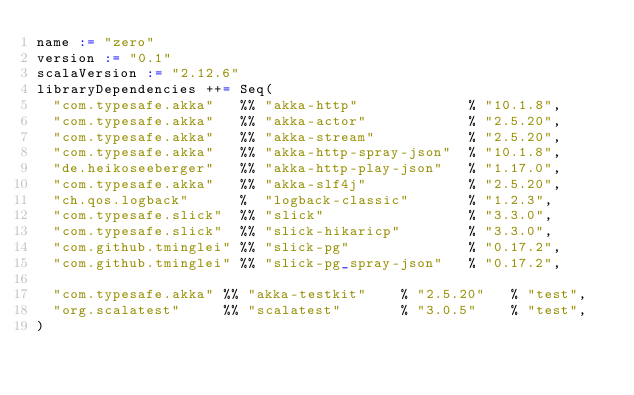<code> <loc_0><loc_0><loc_500><loc_500><_Scala_>name := "zero"
version := "0.1"
scalaVersion := "2.12.6"
libraryDependencies ++= Seq(
  "com.typesafe.akka"   %% "akka-http"             % "10.1.8",
  "com.typesafe.akka"   %% "akka-actor"            % "2.5.20",
  "com.typesafe.akka"   %% "akka-stream"           % "2.5.20",
  "com.typesafe.akka"   %% "akka-http-spray-json"  % "10.1.8",
  "de.heikoseeberger"   %% "akka-http-play-json"   % "1.17.0",
  "com.typesafe.akka"   %% "akka-slf4j"            % "2.5.20",
  "ch.qos.logback"      %  "logback-classic"       % "1.2.3",
  "com.typesafe.slick"  %% "slick"                 % "3.3.0",
  "com.typesafe.slick"  %% "slick-hikaricp"        % "3.3.0",
  "com.github.tminglei" %% "slick-pg"              % "0.17.2",
  "com.github.tminglei" %% "slick-pg_spray-json"   % "0.17.2",
  
  "com.typesafe.akka" %% "akka-testkit"    % "2.5.20"   % "test",
  "org.scalatest"     %% "scalatest"       % "3.0.5"    % "test",
)</code> 